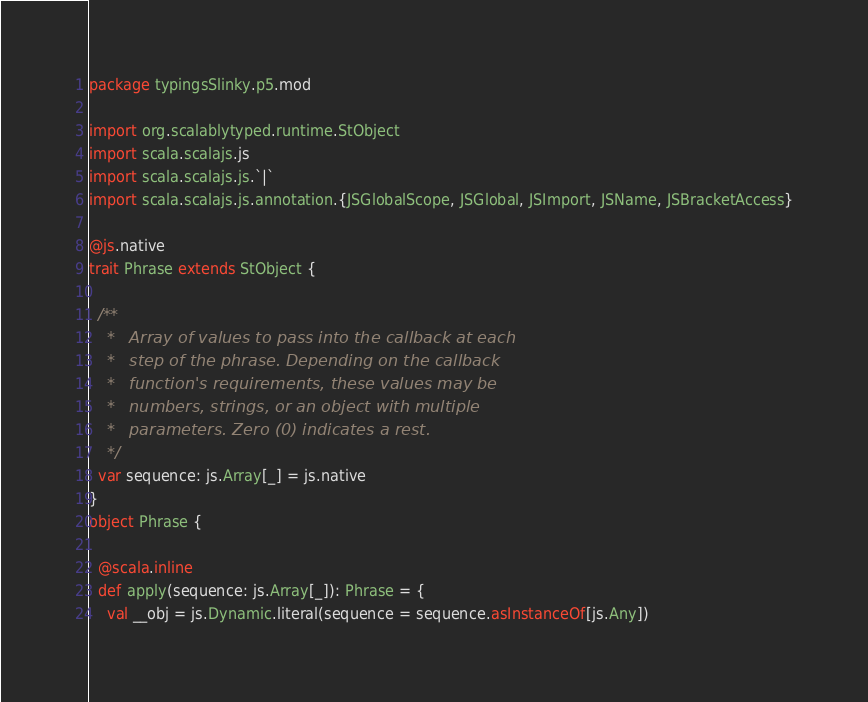<code> <loc_0><loc_0><loc_500><loc_500><_Scala_>package typingsSlinky.p5.mod

import org.scalablytyped.runtime.StObject
import scala.scalajs.js
import scala.scalajs.js.`|`
import scala.scalajs.js.annotation.{JSGlobalScope, JSGlobal, JSImport, JSName, JSBracketAccess}

@js.native
trait Phrase extends StObject {
  
  /**
    *   Array of values to pass into the callback at each
    *   step of the phrase. Depending on the callback
    *   function's requirements, these values may be
    *   numbers, strings, or an object with multiple
    *   parameters. Zero (0) indicates a rest.
    */
  var sequence: js.Array[_] = js.native
}
object Phrase {
  
  @scala.inline
  def apply(sequence: js.Array[_]): Phrase = {
    val __obj = js.Dynamic.literal(sequence = sequence.asInstanceOf[js.Any])</code> 